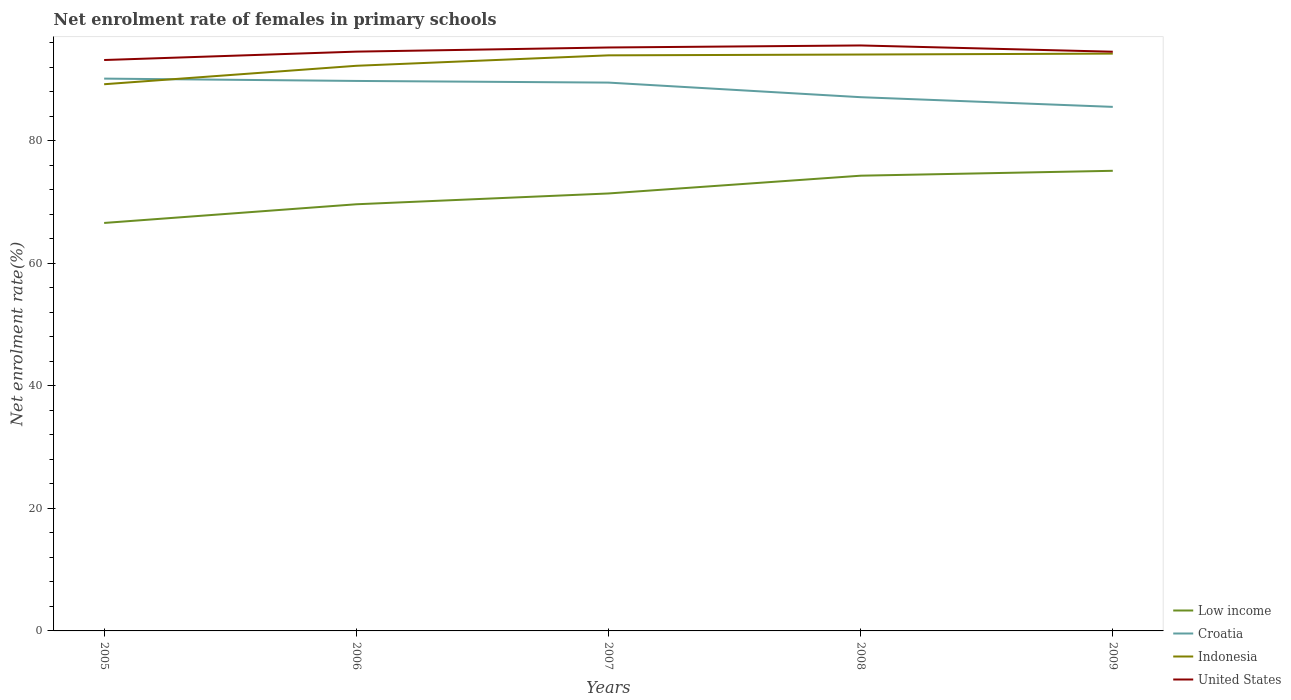How many different coloured lines are there?
Your answer should be compact. 4. Does the line corresponding to Indonesia intersect with the line corresponding to Low income?
Offer a terse response. No. Across all years, what is the maximum net enrolment rate of females in primary schools in Croatia?
Make the answer very short. 85.56. What is the total net enrolment rate of females in primary schools in Indonesia in the graph?
Give a very brief answer. -5. What is the difference between the highest and the second highest net enrolment rate of females in primary schools in United States?
Provide a short and direct response. 2.38. What is the difference between the highest and the lowest net enrolment rate of females in primary schools in Indonesia?
Give a very brief answer. 3. Is the net enrolment rate of females in primary schools in Croatia strictly greater than the net enrolment rate of females in primary schools in United States over the years?
Ensure brevity in your answer.  Yes. Does the graph contain grids?
Your response must be concise. No. Where does the legend appear in the graph?
Provide a succinct answer. Bottom right. How many legend labels are there?
Provide a succinct answer. 4. What is the title of the graph?
Give a very brief answer. Net enrolment rate of females in primary schools. Does "Guinea-Bissau" appear as one of the legend labels in the graph?
Provide a succinct answer. No. What is the label or title of the Y-axis?
Keep it short and to the point. Net enrolment rate(%). What is the Net enrolment rate(%) of Low income in 2005?
Keep it short and to the point. 66.61. What is the Net enrolment rate(%) of Croatia in 2005?
Provide a succinct answer. 90.18. What is the Net enrolment rate(%) of Indonesia in 2005?
Keep it short and to the point. 89.26. What is the Net enrolment rate(%) of United States in 2005?
Provide a short and direct response. 93.22. What is the Net enrolment rate(%) in Low income in 2006?
Ensure brevity in your answer.  69.66. What is the Net enrolment rate(%) in Croatia in 2006?
Make the answer very short. 89.8. What is the Net enrolment rate(%) of Indonesia in 2006?
Ensure brevity in your answer.  92.27. What is the Net enrolment rate(%) in United States in 2006?
Ensure brevity in your answer.  94.58. What is the Net enrolment rate(%) in Low income in 2007?
Give a very brief answer. 71.43. What is the Net enrolment rate(%) of Croatia in 2007?
Your response must be concise. 89.53. What is the Net enrolment rate(%) of Indonesia in 2007?
Provide a succinct answer. 93.98. What is the Net enrolment rate(%) in United States in 2007?
Ensure brevity in your answer.  95.26. What is the Net enrolment rate(%) of Low income in 2008?
Keep it short and to the point. 74.33. What is the Net enrolment rate(%) of Croatia in 2008?
Make the answer very short. 87.15. What is the Net enrolment rate(%) of Indonesia in 2008?
Ensure brevity in your answer.  94.11. What is the Net enrolment rate(%) in United States in 2008?
Your response must be concise. 95.59. What is the Net enrolment rate(%) in Low income in 2009?
Offer a terse response. 75.13. What is the Net enrolment rate(%) of Croatia in 2009?
Your response must be concise. 85.56. What is the Net enrolment rate(%) of Indonesia in 2009?
Ensure brevity in your answer.  94.26. What is the Net enrolment rate(%) in United States in 2009?
Ensure brevity in your answer.  94.57. Across all years, what is the maximum Net enrolment rate(%) in Low income?
Offer a terse response. 75.13. Across all years, what is the maximum Net enrolment rate(%) in Croatia?
Give a very brief answer. 90.18. Across all years, what is the maximum Net enrolment rate(%) of Indonesia?
Provide a succinct answer. 94.26. Across all years, what is the maximum Net enrolment rate(%) in United States?
Your answer should be very brief. 95.59. Across all years, what is the minimum Net enrolment rate(%) of Low income?
Provide a succinct answer. 66.61. Across all years, what is the minimum Net enrolment rate(%) in Croatia?
Offer a very short reply. 85.56. Across all years, what is the minimum Net enrolment rate(%) of Indonesia?
Your answer should be compact. 89.26. Across all years, what is the minimum Net enrolment rate(%) in United States?
Your answer should be very brief. 93.22. What is the total Net enrolment rate(%) in Low income in the graph?
Provide a short and direct response. 357.15. What is the total Net enrolment rate(%) of Croatia in the graph?
Your answer should be very brief. 442.21. What is the total Net enrolment rate(%) of Indonesia in the graph?
Make the answer very short. 463.88. What is the total Net enrolment rate(%) of United States in the graph?
Provide a short and direct response. 473.22. What is the difference between the Net enrolment rate(%) in Low income in 2005 and that in 2006?
Offer a terse response. -3.05. What is the difference between the Net enrolment rate(%) in Croatia in 2005 and that in 2006?
Offer a terse response. 0.38. What is the difference between the Net enrolment rate(%) in Indonesia in 2005 and that in 2006?
Provide a short and direct response. -3.01. What is the difference between the Net enrolment rate(%) of United States in 2005 and that in 2006?
Provide a short and direct response. -1.37. What is the difference between the Net enrolment rate(%) of Low income in 2005 and that in 2007?
Offer a terse response. -4.82. What is the difference between the Net enrolment rate(%) of Croatia in 2005 and that in 2007?
Provide a short and direct response. 0.65. What is the difference between the Net enrolment rate(%) of Indonesia in 2005 and that in 2007?
Offer a very short reply. -4.72. What is the difference between the Net enrolment rate(%) in United States in 2005 and that in 2007?
Your answer should be very brief. -2.04. What is the difference between the Net enrolment rate(%) in Low income in 2005 and that in 2008?
Ensure brevity in your answer.  -7.72. What is the difference between the Net enrolment rate(%) in Croatia in 2005 and that in 2008?
Provide a short and direct response. 3.03. What is the difference between the Net enrolment rate(%) in Indonesia in 2005 and that in 2008?
Provide a short and direct response. -4.85. What is the difference between the Net enrolment rate(%) of United States in 2005 and that in 2008?
Ensure brevity in your answer.  -2.38. What is the difference between the Net enrolment rate(%) of Low income in 2005 and that in 2009?
Your answer should be very brief. -8.52. What is the difference between the Net enrolment rate(%) in Croatia in 2005 and that in 2009?
Your answer should be compact. 4.61. What is the difference between the Net enrolment rate(%) of Indonesia in 2005 and that in 2009?
Provide a short and direct response. -5. What is the difference between the Net enrolment rate(%) of United States in 2005 and that in 2009?
Your answer should be compact. -1.36. What is the difference between the Net enrolment rate(%) of Low income in 2006 and that in 2007?
Your response must be concise. -1.77. What is the difference between the Net enrolment rate(%) of Croatia in 2006 and that in 2007?
Your answer should be compact. 0.27. What is the difference between the Net enrolment rate(%) in Indonesia in 2006 and that in 2007?
Ensure brevity in your answer.  -1.7. What is the difference between the Net enrolment rate(%) in United States in 2006 and that in 2007?
Keep it short and to the point. -0.68. What is the difference between the Net enrolment rate(%) of Low income in 2006 and that in 2008?
Ensure brevity in your answer.  -4.67. What is the difference between the Net enrolment rate(%) in Croatia in 2006 and that in 2008?
Give a very brief answer. 2.65. What is the difference between the Net enrolment rate(%) of Indonesia in 2006 and that in 2008?
Your response must be concise. -1.84. What is the difference between the Net enrolment rate(%) of United States in 2006 and that in 2008?
Provide a succinct answer. -1.01. What is the difference between the Net enrolment rate(%) of Low income in 2006 and that in 2009?
Keep it short and to the point. -5.46. What is the difference between the Net enrolment rate(%) in Croatia in 2006 and that in 2009?
Offer a very short reply. 4.24. What is the difference between the Net enrolment rate(%) in Indonesia in 2006 and that in 2009?
Make the answer very short. -1.99. What is the difference between the Net enrolment rate(%) of United States in 2006 and that in 2009?
Your answer should be very brief. 0.01. What is the difference between the Net enrolment rate(%) in Low income in 2007 and that in 2008?
Make the answer very short. -2.9. What is the difference between the Net enrolment rate(%) of Croatia in 2007 and that in 2008?
Offer a very short reply. 2.38. What is the difference between the Net enrolment rate(%) in Indonesia in 2007 and that in 2008?
Your answer should be very brief. -0.13. What is the difference between the Net enrolment rate(%) of United States in 2007 and that in 2008?
Make the answer very short. -0.33. What is the difference between the Net enrolment rate(%) in Low income in 2007 and that in 2009?
Provide a succinct answer. -3.7. What is the difference between the Net enrolment rate(%) of Croatia in 2007 and that in 2009?
Your answer should be very brief. 3.97. What is the difference between the Net enrolment rate(%) in Indonesia in 2007 and that in 2009?
Offer a very short reply. -0.28. What is the difference between the Net enrolment rate(%) in United States in 2007 and that in 2009?
Your answer should be compact. 0.69. What is the difference between the Net enrolment rate(%) of Low income in 2008 and that in 2009?
Offer a terse response. -0.8. What is the difference between the Net enrolment rate(%) of Croatia in 2008 and that in 2009?
Make the answer very short. 1.58. What is the difference between the Net enrolment rate(%) in Indonesia in 2008 and that in 2009?
Make the answer very short. -0.15. What is the difference between the Net enrolment rate(%) of United States in 2008 and that in 2009?
Keep it short and to the point. 1.02. What is the difference between the Net enrolment rate(%) in Low income in 2005 and the Net enrolment rate(%) in Croatia in 2006?
Make the answer very short. -23.19. What is the difference between the Net enrolment rate(%) in Low income in 2005 and the Net enrolment rate(%) in Indonesia in 2006?
Your response must be concise. -25.66. What is the difference between the Net enrolment rate(%) in Low income in 2005 and the Net enrolment rate(%) in United States in 2006?
Provide a succinct answer. -27.97. What is the difference between the Net enrolment rate(%) in Croatia in 2005 and the Net enrolment rate(%) in Indonesia in 2006?
Ensure brevity in your answer.  -2.09. What is the difference between the Net enrolment rate(%) of Croatia in 2005 and the Net enrolment rate(%) of United States in 2006?
Provide a succinct answer. -4.41. What is the difference between the Net enrolment rate(%) in Indonesia in 2005 and the Net enrolment rate(%) in United States in 2006?
Provide a short and direct response. -5.32. What is the difference between the Net enrolment rate(%) in Low income in 2005 and the Net enrolment rate(%) in Croatia in 2007?
Your answer should be compact. -22.92. What is the difference between the Net enrolment rate(%) of Low income in 2005 and the Net enrolment rate(%) of Indonesia in 2007?
Offer a terse response. -27.37. What is the difference between the Net enrolment rate(%) of Low income in 2005 and the Net enrolment rate(%) of United States in 2007?
Offer a very short reply. -28.65. What is the difference between the Net enrolment rate(%) in Croatia in 2005 and the Net enrolment rate(%) in Indonesia in 2007?
Make the answer very short. -3.8. What is the difference between the Net enrolment rate(%) in Croatia in 2005 and the Net enrolment rate(%) in United States in 2007?
Ensure brevity in your answer.  -5.08. What is the difference between the Net enrolment rate(%) in Indonesia in 2005 and the Net enrolment rate(%) in United States in 2007?
Offer a terse response. -6. What is the difference between the Net enrolment rate(%) of Low income in 2005 and the Net enrolment rate(%) of Croatia in 2008?
Your answer should be compact. -20.53. What is the difference between the Net enrolment rate(%) of Low income in 2005 and the Net enrolment rate(%) of Indonesia in 2008?
Provide a succinct answer. -27.5. What is the difference between the Net enrolment rate(%) of Low income in 2005 and the Net enrolment rate(%) of United States in 2008?
Provide a succinct answer. -28.98. What is the difference between the Net enrolment rate(%) of Croatia in 2005 and the Net enrolment rate(%) of Indonesia in 2008?
Provide a short and direct response. -3.93. What is the difference between the Net enrolment rate(%) of Croatia in 2005 and the Net enrolment rate(%) of United States in 2008?
Make the answer very short. -5.42. What is the difference between the Net enrolment rate(%) in Indonesia in 2005 and the Net enrolment rate(%) in United States in 2008?
Your answer should be compact. -6.33. What is the difference between the Net enrolment rate(%) of Low income in 2005 and the Net enrolment rate(%) of Croatia in 2009?
Your answer should be very brief. -18.95. What is the difference between the Net enrolment rate(%) in Low income in 2005 and the Net enrolment rate(%) in Indonesia in 2009?
Ensure brevity in your answer.  -27.65. What is the difference between the Net enrolment rate(%) in Low income in 2005 and the Net enrolment rate(%) in United States in 2009?
Offer a very short reply. -27.96. What is the difference between the Net enrolment rate(%) of Croatia in 2005 and the Net enrolment rate(%) of Indonesia in 2009?
Provide a short and direct response. -4.08. What is the difference between the Net enrolment rate(%) in Croatia in 2005 and the Net enrolment rate(%) in United States in 2009?
Keep it short and to the point. -4.39. What is the difference between the Net enrolment rate(%) in Indonesia in 2005 and the Net enrolment rate(%) in United States in 2009?
Make the answer very short. -5.31. What is the difference between the Net enrolment rate(%) in Low income in 2006 and the Net enrolment rate(%) in Croatia in 2007?
Make the answer very short. -19.87. What is the difference between the Net enrolment rate(%) in Low income in 2006 and the Net enrolment rate(%) in Indonesia in 2007?
Provide a succinct answer. -24.32. What is the difference between the Net enrolment rate(%) in Low income in 2006 and the Net enrolment rate(%) in United States in 2007?
Make the answer very short. -25.6. What is the difference between the Net enrolment rate(%) in Croatia in 2006 and the Net enrolment rate(%) in Indonesia in 2007?
Your answer should be very brief. -4.18. What is the difference between the Net enrolment rate(%) of Croatia in 2006 and the Net enrolment rate(%) of United States in 2007?
Offer a terse response. -5.46. What is the difference between the Net enrolment rate(%) of Indonesia in 2006 and the Net enrolment rate(%) of United States in 2007?
Your answer should be very brief. -2.99. What is the difference between the Net enrolment rate(%) of Low income in 2006 and the Net enrolment rate(%) of Croatia in 2008?
Make the answer very short. -17.48. What is the difference between the Net enrolment rate(%) of Low income in 2006 and the Net enrolment rate(%) of Indonesia in 2008?
Provide a succinct answer. -24.45. What is the difference between the Net enrolment rate(%) in Low income in 2006 and the Net enrolment rate(%) in United States in 2008?
Provide a short and direct response. -25.93. What is the difference between the Net enrolment rate(%) in Croatia in 2006 and the Net enrolment rate(%) in Indonesia in 2008?
Give a very brief answer. -4.31. What is the difference between the Net enrolment rate(%) in Croatia in 2006 and the Net enrolment rate(%) in United States in 2008?
Your response must be concise. -5.79. What is the difference between the Net enrolment rate(%) in Indonesia in 2006 and the Net enrolment rate(%) in United States in 2008?
Make the answer very short. -3.32. What is the difference between the Net enrolment rate(%) in Low income in 2006 and the Net enrolment rate(%) in Croatia in 2009?
Offer a terse response. -15.9. What is the difference between the Net enrolment rate(%) of Low income in 2006 and the Net enrolment rate(%) of Indonesia in 2009?
Offer a very short reply. -24.6. What is the difference between the Net enrolment rate(%) in Low income in 2006 and the Net enrolment rate(%) in United States in 2009?
Offer a terse response. -24.91. What is the difference between the Net enrolment rate(%) in Croatia in 2006 and the Net enrolment rate(%) in Indonesia in 2009?
Your response must be concise. -4.46. What is the difference between the Net enrolment rate(%) of Croatia in 2006 and the Net enrolment rate(%) of United States in 2009?
Your response must be concise. -4.77. What is the difference between the Net enrolment rate(%) of Indonesia in 2006 and the Net enrolment rate(%) of United States in 2009?
Keep it short and to the point. -2.3. What is the difference between the Net enrolment rate(%) in Low income in 2007 and the Net enrolment rate(%) in Croatia in 2008?
Ensure brevity in your answer.  -15.72. What is the difference between the Net enrolment rate(%) in Low income in 2007 and the Net enrolment rate(%) in Indonesia in 2008?
Your answer should be compact. -22.68. What is the difference between the Net enrolment rate(%) of Low income in 2007 and the Net enrolment rate(%) of United States in 2008?
Provide a short and direct response. -24.17. What is the difference between the Net enrolment rate(%) in Croatia in 2007 and the Net enrolment rate(%) in Indonesia in 2008?
Your response must be concise. -4.58. What is the difference between the Net enrolment rate(%) in Croatia in 2007 and the Net enrolment rate(%) in United States in 2008?
Offer a very short reply. -6.06. What is the difference between the Net enrolment rate(%) of Indonesia in 2007 and the Net enrolment rate(%) of United States in 2008?
Provide a short and direct response. -1.62. What is the difference between the Net enrolment rate(%) of Low income in 2007 and the Net enrolment rate(%) of Croatia in 2009?
Keep it short and to the point. -14.14. What is the difference between the Net enrolment rate(%) of Low income in 2007 and the Net enrolment rate(%) of Indonesia in 2009?
Provide a short and direct response. -22.84. What is the difference between the Net enrolment rate(%) of Low income in 2007 and the Net enrolment rate(%) of United States in 2009?
Provide a short and direct response. -23.14. What is the difference between the Net enrolment rate(%) in Croatia in 2007 and the Net enrolment rate(%) in Indonesia in 2009?
Offer a terse response. -4.73. What is the difference between the Net enrolment rate(%) of Croatia in 2007 and the Net enrolment rate(%) of United States in 2009?
Provide a short and direct response. -5.04. What is the difference between the Net enrolment rate(%) of Indonesia in 2007 and the Net enrolment rate(%) of United States in 2009?
Offer a terse response. -0.59. What is the difference between the Net enrolment rate(%) in Low income in 2008 and the Net enrolment rate(%) in Croatia in 2009?
Your answer should be compact. -11.24. What is the difference between the Net enrolment rate(%) of Low income in 2008 and the Net enrolment rate(%) of Indonesia in 2009?
Offer a terse response. -19.93. What is the difference between the Net enrolment rate(%) in Low income in 2008 and the Net enrolment rate(%) in United States in 2009?
Offer a terse response. -20.24. What is the difference between the Net enrolment rate(%) in Croatia in 2008 and the Net enrolment rate(%) in Indonesia in 2009?
Offer a terse response. -7.12. What is the difference between the Net enrolment rate(%) in Croatia in 2008 and the Net enrolment rate(%) in United States in 2009?
Make the answer very short. -7.43. What is the difference between the Net enrolment rate(%) in Indonesia in 2008 and the Net enrolment rate(%) in United States in 2009?
Give a very brief answer. -0.46. What is the average Net enrolment rate(%) of Low income per year?
Offer a terse response. 71.43. What is the average Net enrolment rate(%) of Croatia per year?
Your answer should be compact. 88.44. What is the average Net enrolment rate(%) of Indonesia per year?
Give a very brief answer. 92.78. What is the average Net enrolment rate(%) in United States per year?
Make the answer very short. 94.64. In the year 2005, what is the difference between the Net enrolment rate(%) in Low income and Net enrolment rate(%) in Croatia?
Provide a short and direct response. -23.57. In the year 2005, what is the difference between the Net enrolment rate(%) of Low income and Net enrolment rate(%) of Indonesia?
Give a very brief answer. -22.65. In the year 2005, what is the difference between the Net enrolment rate(%) in Low income and Net enrolment rate(%) in United States?
Offer a terse response. -26.6. In the year 2005, what is the difference between the Net enrolment rate(%) in Croatia and Net enrolment rate(%) in Indonesia?
Keep it short and to the point. 0.92. In the year 2005, what is the difference between the Net enrolment rate(%) of Croatia and Net enrolment rate(%) of United States?
Your answer should be very brief. -3.04. In the year 2005, what is the difference between the Net enrolment rate(%) of Indonesia and Net enrolment rate(%) of United States?
Provide a succinct answer. -3.96. In the year 2006, what is the difference between the Net enrolment rate(%) in Low income and Net enrolment rate(%) in Croatia?
Your answer should be compact. -20.14. In the year 2006, what is the difference between the Net enrolment rate(%) of Low income and Net enrolment rate(%) of Indonesia?
Offer a very short reply. -22.61. In the year 2006, what is the difference between the Net enrolment rate(%) in Low income and Net enrolment rate(%) in United States?
Make the answer very short. -24.92. In the year 2006, what is the difference between the Net enrolment rate(%) of Croatia and Net enrolment rate(%) of Indonesia?
Give a very brief answer. -2.47. In the year 2006, what is the difference between the Net enrolment rate(%) of Croatia and Net enrolment rate(%) of United States?
Provide a succinct answer. -4.79. In the year 2006, what is the difference between the Net enrolment rate(%) in Indonesia and Net enrolment rate(%) in United States?
Make the answer very short. -2.31. In the year 2007, what is the difference between the Net enrolment rate(%) of Low income and Net enrolment rate(%) of Croatia?
Your answer should be compact. -18.1. In the year 2007, what is the difference between the Net enrolment rate(%) of Low income and Net enrolment rate(%) of Indonesia?
Provide a short and direct response. -22.55. In the year 2007, what is the difference between the Net enrolment rate(%) of Low income and Net enrolment rate(%) of United States?
Offer a terse response. -23.83. In the year 2007, what is the difference between the Net enrolment rate(%) in Croatia and Net enrolment rate(%) in Indonesia?
Your answer should be very brief. -4.45. In the year 2007, what is the difference between the Net enrolment rate(%) in Croatia and Net enrolment rate(%) in United States?
Make the answer very short. -5.73. In the year 2007, what is the difference between the Net enrolment rate(%) in Indonesia and Net enrolment rate(%) in United States?
Your response must be concise. -1.28. In the year 2008, what is the difference between the Net enrolment rate(%) of Low income and Net enrolment rate(%) of Croatia?
Provide a short and direct response. -12.82. In the year 2008, what is the difference between the Net enrolment rate(%) of Low income and Net enrolment rate(%) of Indonesia?
Ensure brevity in your answer.  -19.78. In the year 2008, what is the difference between the Net enrolment rate(%) in Low income and Net enrolment rate(%) in United States?
Your response must be concise. -21.27. In the year 2008, what is the difference between the Net enrolment rate(%) of Croatia and Net enrolment rate(%) of Indonesia?
Your answer should be compact. -6.96. In the year 2008, what is the difference between the Net enrolment rate(%) of Croatia and Net enrolment rate(%) of United States?
Offer a very short reply. -8.45. In the year 2008, what is the difference between the Net enrolment rate(%) in Indonesia and Net enrolment rate(%) in United States?
Keep it short and to the point. -1.48. In the year 2009, what is the difference between the Net enrolment rate(%) of Low income and Net enrolment rate(%) of Croatia?
Make the answer very short. -10.44. In the year 2009, what is the difference between the Net enrolment rate(%) in Low income and Net enrolment rate(%) in Indonesia?
Ensure brevity in your answer.  -19.14. In the year 2009, what is the difference between the Net enrolment rate(%) in Low income and Net enrolment rate(%) in United States?
Keep it short and to the point. -19.44. In the year 2009, what is the difference between the Net enrolment rate(%) of Croatia and Net enrolment rate(%) of Indonesia?
Make the answer very short. -8.7. In the year 2009, what is the difference between the Net enrolment rate(%) in Croatia and Net enrolment rate(%) in United States?
Give a very brief answer. -9.01. In the year 2009, what is the difference between the Net enrolment rate(%) in Indonesia and Net enrolment rate(%) in United States?
Keep it short and to the point. -0.31. What is the ratio of the Net enrolment rate(%) of Low income in 2005 to that in 2006?
Make the answer very short. 0.96. What is the ratio of the Net enrolment rate(%) of Indonesia in 2005 to that in 2006?
Provide a short and direct response. 0.97. What is the ratio of the Net enrolment rate(%) of United States in 2005 to that in 2006?
Keep it short and to the point. 0.99. What is the ratio of the Net enrolment rate(%) in Low income in 2005 to that in 2007?
Offer a terse response. 0.93. What is the ratio of the Net enrolment rate(%) in Croatia in 2005 to that in 2007?
Make the answer very short. 1.01. What is the ratio of the Net enrolment rate(%) in Indonesia in 2005 to that in 2007?
Your answer should be compact. 0.95. What is the ratio of the Net enrolment rate(%) in United States in 2005 to that in 2007?
Give a very brief answer. 0.98. What is the ratio of the Net enrolment rate(%) of Low income in 2005 to that in 2008?
Ensure brevity in your answer.  0.9. What is the ratio of the Net enrolment rate(%) in Croatia in 2005 to that in 2008?
Provide a succinct answer. 1.03. What is the ratio of the Net enrolment rate(%) of Indonesia in 2005 to that in 2008?
Your response must be concise. 0.95. What is the ratio of the Net enrolment rate(%) in United States in 2005 to that in 2008?
Make the answer very short. 0.98. What is the ratio of the Net enrolment rate(%) in Low income in 2005 to that in 2009?
Offer a very short reply. 0.89. What is the ratio of the Net enrolment rate(%) in Croatia in 2005 to that in 2009?
Make the answer very short. 1.05. What is the ratio of the Net enrolment rate(%) of Indonesia in 2005 to that in 2009?
Offer a terse response. 0.95. What is the ratio of the Net enrolment rate(%) in United States in 2005 to that in 2009?
Your answer should be very brief. 0.99. What is the ratio of the Net enrolment rate(%) in Low income in 2006 to that in 2007?
Ensure brevity in your answer.  0.98. What is the ratio of the Net enrolment rate(%) in Indonesia in 2006 to that in 2007?
Provide a short and direct response. 0.98. What is the ratio of the Net enrolment rate(%) of United States in 2006 to that in 2007?
Offer a terse response. 0.99. What is the ratio of the Net enrolment rate(%) in Low income in 2006 to that in 2008?
Offer a very short reply. 0.94. What is the ratio of the Net enrolment rate(%) in Croatia in 2006 to that in 2008?
Keep it short and to the point. 1.03. What is the ratio of the Net enrolment rate(%) in Indonesia in 2006 to that in 2008?
Provide a succinct answer. 0.98. What is the ratio of the Net enrolment rate(%) in United States in 2006 to that in 2008?
Give a very brief answer. 0.99. What is the ratio of the Net enrolment rate(%) of Low income in 2006 to that in 2009?
Your response must be concise. 0.93. What is the ratio of the Net enrolment rate(%) in Croatia in 2006 to that in 2009?
Make the answer very short. 1.05. What is the ratio of the Net enrolment rate(%) of Indonesia in 2006 to that in 2009?
Your response must be concise. 0.98. What is the ratio of the Net enrolment rate(%) in United States in 2006 to that in 2009?
Ensure brevity in your answer.  1. What is the ratio of the Net enrolment rate(%) in Croatia in 2007 to that in 2008?
Your answer should be compact. 1.03. What is the ratio of the Net enrolment rate(%) in United States in 2007 to that in 2008?
Your answer should be very brief. 1. What is the ratio of the Net enrolment rate(%) in Low income in 2007 to that in 2009?
Your response must be concise. 0.95. What is the ratio of the Net enrolment rate(%) in Croatia in 2007 to that in 2009?
Offer a terse response. 1.05. What is the ratio of the Net enrolment rate(%) of Indonesia in 2007 to that in 2009?
Offer a terse response. 1. What is the ratio of the Net enrolment rate(%) in United States in 2007 to that in 2009?
Make the answer very short. 1.01. What is the ratio of the Net enrolment rate(%) of Low income in 2008 to that in 2009?
Offer a terse response. 0.99. What is the ratio of the Net enrolment rate(%) in Croatia in 2008 to that in 2009?
Your answer should be compact. 1.02. What is the ratio of the Net enrolment rate(%) in United States in 2008 to that in 2009?
Provide a succinct answer. 1.01. What is the difference between the highest and the second highest Net enrolment rate(%) in Low income?
Your response must be concise. 0.8. What is the difference between the highest and the second highest Net enrolment rate(%) of Croatia?
Provide a succinct answer. 0.38. What is the difference between the highest and the second highest Net enrolment rate(%) of Indonesia?
Provide a succinct answer. 0.15. What is the difference between the highest and the second highest Net enrolment rate(%) in United States?
Your response must be concise. 0.33. What is the difference between the highest and the lowest Net enrolment rate(%) of Low income?
Your answer should be very brief. 8.52. What is the difference between the highest and the lowest Net enrolment rate(%) of Croatia?
Give a very brief answer. 4.61. What is the difference between the highest and the lowest Net enrolment rate(%) of Indonesia?
Ensure brevity in your answer.  5. What is the difference between the highest and the lowest Net enrolment rate(%) of United States?
Your response must be concise. 2.38. 